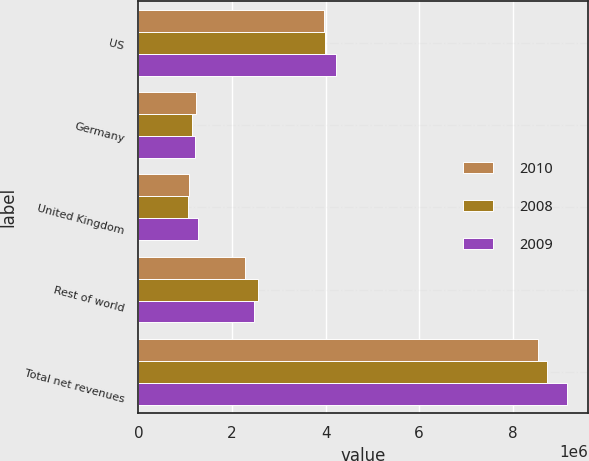Convert chart. <chart><loc_0><loc_0><loc_500><loc_500><stacked_bar_chart><ecel><fcel>US<fcel>Germany<fcel>United Kingdom<fcel>Rest of world<fcel>Total net revenues<nl><fcel>2010<fcel>3.96948e+06<fcel>1.22069e+06<fcel>1.07286e+06<fcel>2.27822e+06<fcel>8.54126e+06<nl><fcel>2008<fcel>3.98507e+06<fcel>1.1402e+06<fcel>1.05473e+06<fcel>2.54736e+06<fcel>8.72736e+06<nl><fcel>2009<fcel>4.21422e+06<fcel>1.20406e+06<fcel>1.2666e+06<fcel>2.4714e+06<fcel>9.15627e+06<nl></chart> 